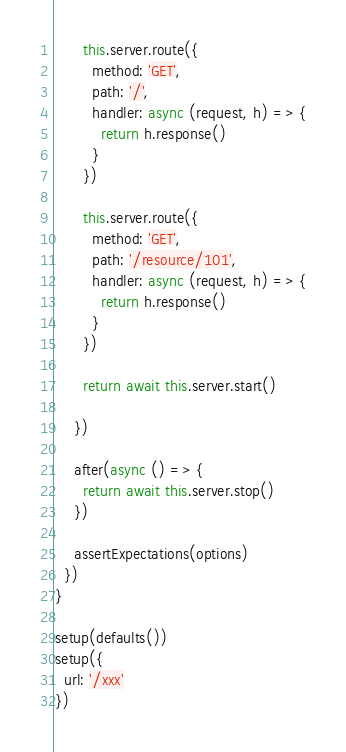Convert code to text. <code><loc_0><loc_0><loc_500><loc_500><_JavaScript_>
      this.server.route({
        method: 'GET',
        path: '/',
        handler: async (request, h) => {
          return h.response()
        }
      })

      this.server.route({
        method: 'GET',
        path: '/resource/101',
        handler: async (request, h) => {
          return h.response()
        }
      })

      return await this.server.start()

    })

    after(async () => {
      return await this.server.stop()
    })

    assertExpectations(options)
  })
}

setup(defaults())
setup({
  url: '/xxx'
})
</code> 